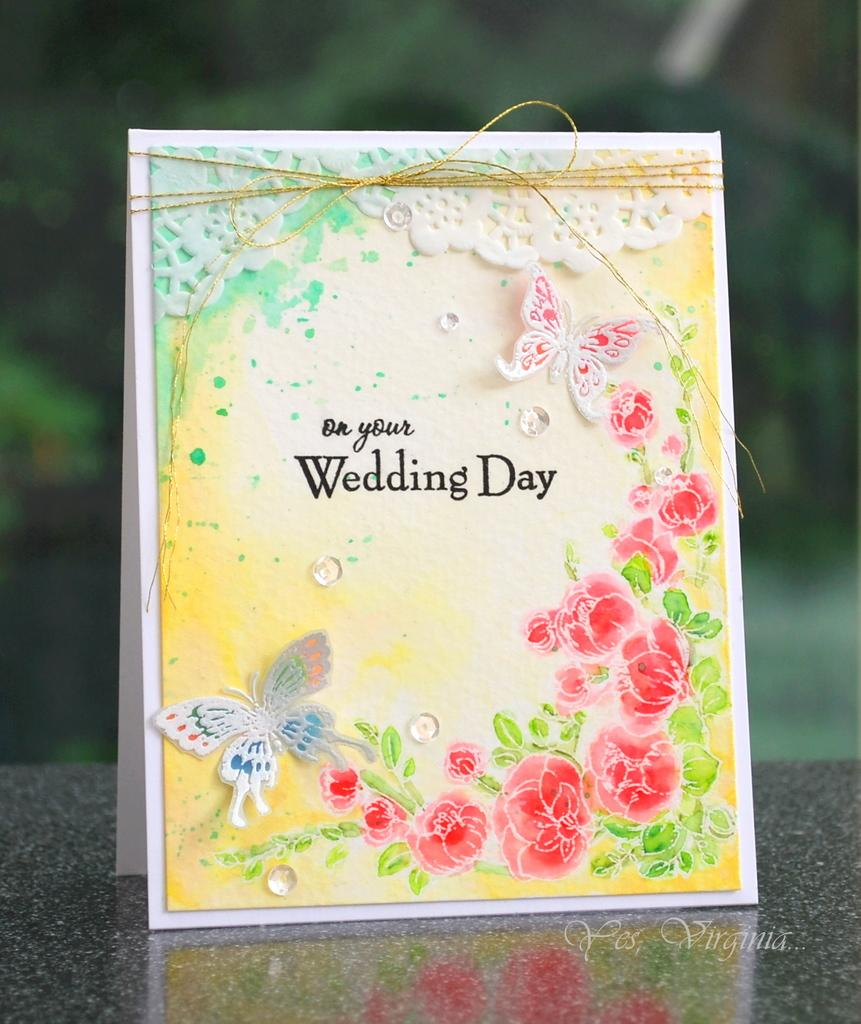What is the main object in the image? There is a wedding card in the image. Where is the wedding card located? The wedding card is placed on a desk. What can be seen in the background of the image? There are trees in the background of the image. What type of pail can be seen in the image? There is no pail present in the image. 